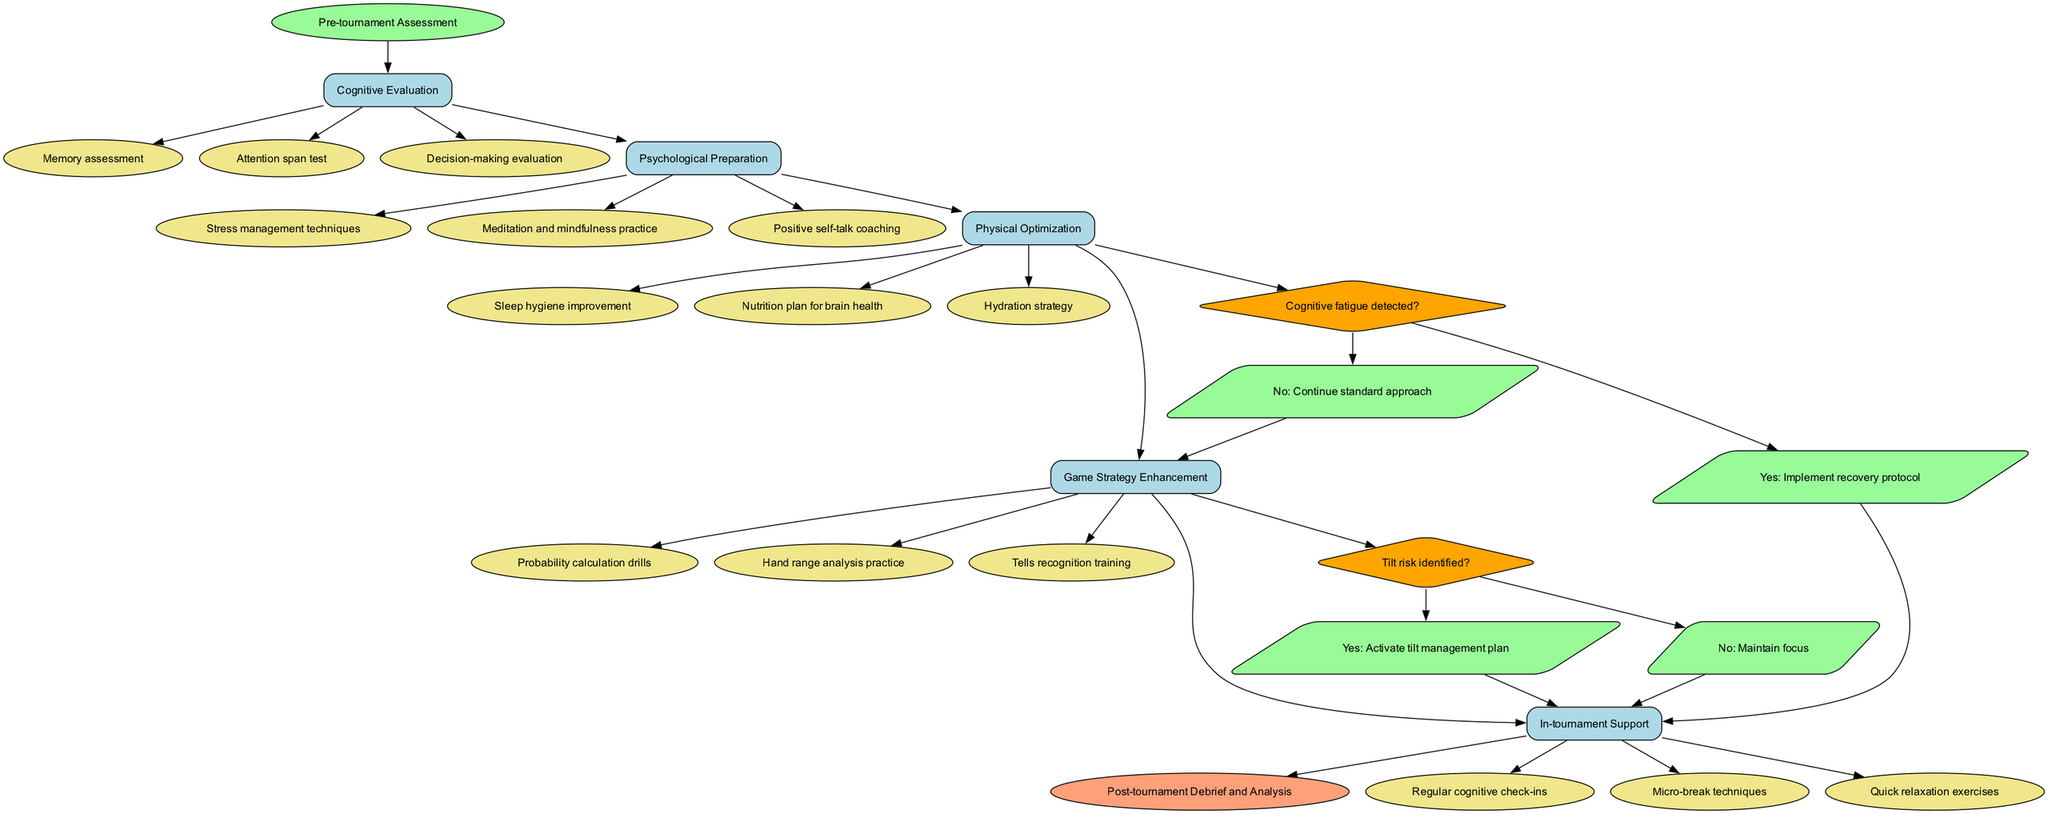What is the starting point of the clinical pathway? The diagram begins with a node labeled "Pre-tournament Assessment," which indicates the initial step or entry point of the clinical pathway.
Answer: Pre-tournament Assessment How many clinical steps are there in total? The diagram lists five distinct steps sequentially, each represented by its own node. Counting these nodes shows there are five clinical steps.
Answer: 5 What action is associated with the "Cognitive Evaluation" step? The diagram includes a list of actions under the "Cognitive Evaluation" step, one of which is "Memory assessment." This directly addresses the action linked to this specific step.
Answer: Memory assessment What happens if cognitive fatigue is detected? According to the decision point in the diagram, if cognitive fatigue is detected, the pathway leads to the implementation of a recovery protocol, specifying the action taken in this scenario.
Answer: Implement recovery protocol Which clinical step follows "Psychological Preparation"? The diagram illustrates a flow where each clinical step connects to the next. After "Psychological Preparation," the subsequent step depicted is "Physical Optimization," showing the consecutive order of the steps.
Answer: Physical Optimization What is the end point of the clinical pathway? The diagram concludes with a node labeled "Post-tournament Debrief and Analysis," indicating the final outcome or exit point of the clinical pathway.
Answer: Post-tournament Debrief and Analysis What decision point checks for tilt risk? The diagram depicts a decision point with the question, "Tilt risk identified?" which signifies the evaluation phase regarding tilt risk during the process.
Answer: Tilt risk identified? If the answer to the cognitive fatigue question is no, which step is continued? If the answer to the cognitive fatigue question is "No," the diagram indicates that the pathway continues with the "Game Strategy Enhancement" step as the subsequent node.
Answer: Game Strategy Enhancement How many actions are listed under "Physical Optimization"? There are three specific actions detailed in the diagram under the "Physical Optimization" step: "Sleep hygiene improvement," "Nutrition plan for brain health," and "Hydration strategy," which can be counted.
Answer: 3 